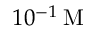Convert formula to latex. <formula><loc_0><loc_0><loc_500><loc_500>1 0 ^ { - 1 } \, M</formula> 